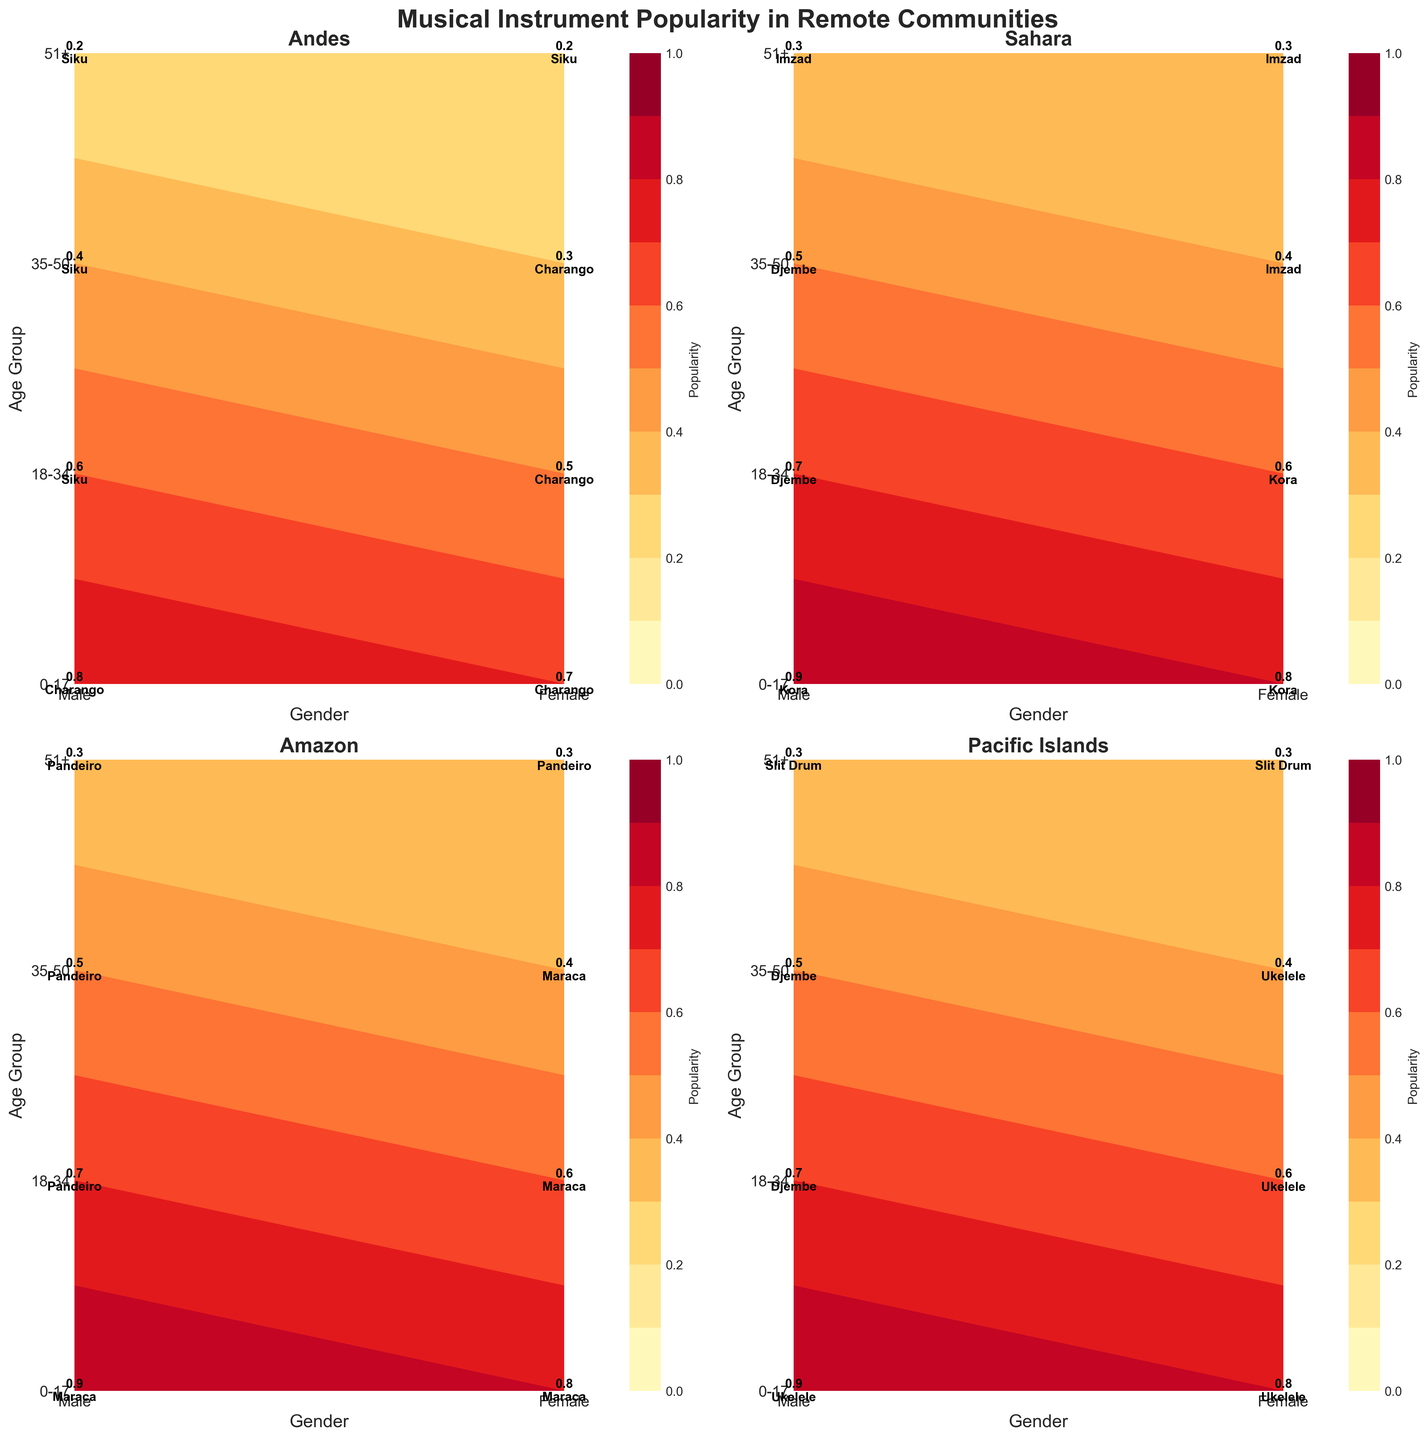Which community has the highest popularity of instruments for males aged 0-17? The Andes, Sahara, Amazon, and Pacific Islands all show the popularity for males aged 0-17. The highest value in this range can be seen in the Sahara with a popularity of 0.9 for the Kora.
Answer: Sahara What is the average popularity of the Charango in the Andes for females across all age groups? For the Andes community, look at the values of the Charango for females across all age groups: 0-17 (0.7), 18-34 (0.5), and 35-50 (0.3). There is no Charango popularity data for females aged 51+. The average is (0.7 + 0.5 + 0.3) / 3 = 1.5 / 3 = 0.5.
Answer: 0.5 Which age group in the Pacific Islands has the lowest instrument popularity for males? In the Pacific Islands, the popularity data for males across all age groups is: 0-17 (0.9 for Ukelele), 18-34 (0.7 for Djembe), 35-50 (0.5 for Djembe), and 51+ (0.3 for Slit Drum). The lowest value is 0.3 for the 51+ age group.
Answer: 51+ Is the popularity of instruments higher for females in the Amazon or the Sahara for the age group 35-50? Compare the popularity of instruments for females aged 35-50 in the Amazon (0.4 for Maraca) and the Sahara (0.4 for Imzad). Both have equal popularity of 0.4.
Answer: They are the same Which community has the most evenly distributed popularity of instruments across all age groups and genders? Calculate the standard deviation of popularity values across all age groups and genders for each community. The community with the lowest standard deviation indicates the most even distribution. Comparing each, the Andes have values like (0.8, 0.7, 0.6, 0.5, 0.4, 0.3, 0.2, 0.2), etc. with likely different variations. This requires manual calculations for each community, determining the lowest deviation.
Answer: Needs calculation What is the combined popularity of Pandeiro in the Amazon for males aged 18-50? Sum the popularity of Pandeiro in the Amazon for males aged 18-34 (0.7) and 35-50 (0.5). The combined popularity is 0.7 + 0.5 = 1.2.
Answer: 1.2 